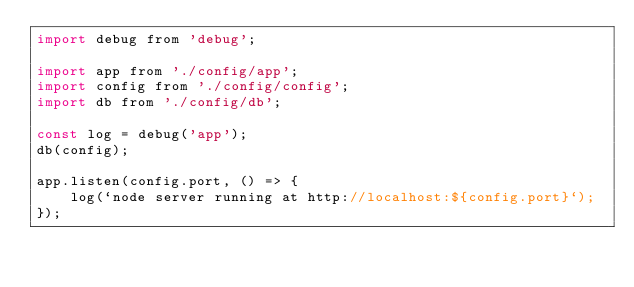Convert code to text. <code><loc_0><loc_0><loc_500><loc_500><_JavaScript_>import debug from 'debug';

import app from './config/app';
import config from './config/config';
import db from './config/db';

const log = debug('app');
db(config);

app.listen(config.port, () => {
    log(`node server running at http://localhost:${config.port}`);
});
</code> 